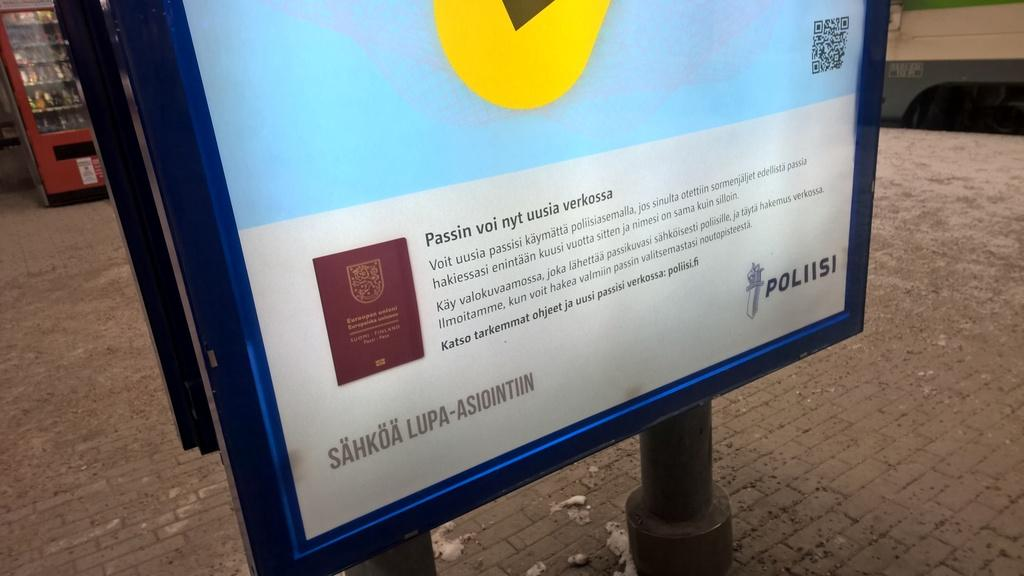<image>
Offer a succinct explanation of the picture presented. A lit sign includes the name Poliisi in the bottom corner. 